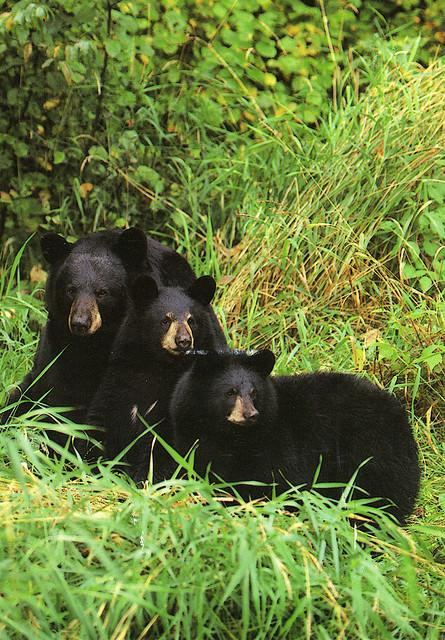What kind of diet do they adhere to?

Choices:
A) carnivore
B) omnivore
C) monophagous
D) herbivore omnivore 